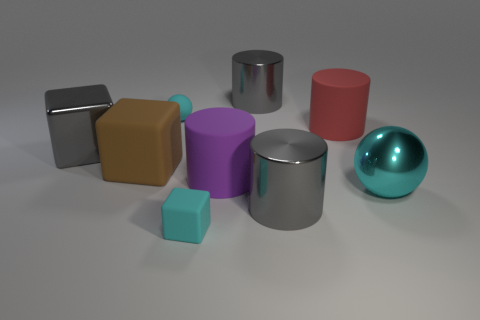Is the number of brown cubes that are behind the big red matte cylinder greater than the number of large matte blocks that are behind the gray cube?
Your answer should be compact. No. There is a tiny object that is in front of the brown rubber cube; what color is it?
Offer a terse response. Cyan. There is a metallic cylinder that is behind the red matte cylinder; is its size the same as the purple rubber cylinder to the left of the cyan metallic ball?
Provide a short and direct response. Yes. How many objects are either big red objects or tiny yellow matte balls?
Ensure brevity in your answer.  1. What material is the sphere to the right of the tiny thing in front of the brown rubber cube made of?
Offer a very short reply. Metal. How many other things are the same shape as the purple object?
Give a very brief answer. 3. Is there a shiny cylinder of the same color as the shiny cube?
Make the answer very short. Yes. What number of things are either big shiny cylinders that are behind the big red matte cylinder or cyan rubber things in front of the brown matte object?
Keep it short and to the point. 2. Is there a large object to the right of the metallic cylinder that is behind the purple matte cylinder?
Offer a terse response. Yes. What shape is the object that is the same size as the matte sphere?
Your response must be concise. Cube. 